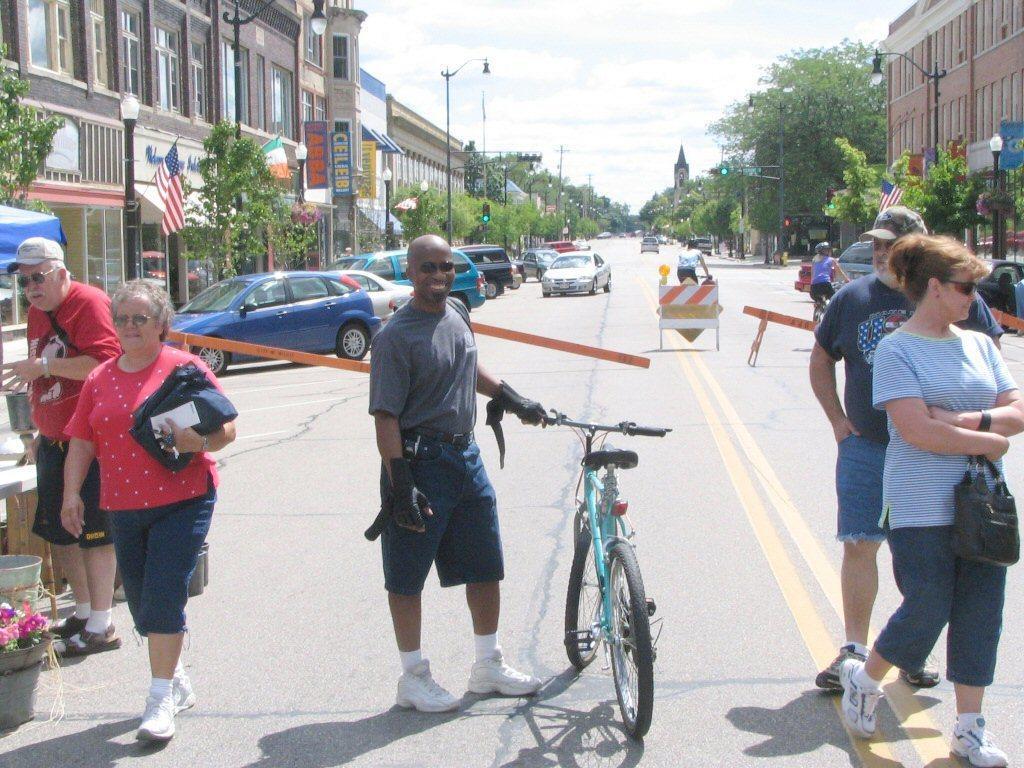Please provide a concise description of this image. The picture contains some people are walking on the road and some people are riding the cycle the right side the car is parked and left side also car is parked behind the person there are so many trees and building are there background is very cloudy. 